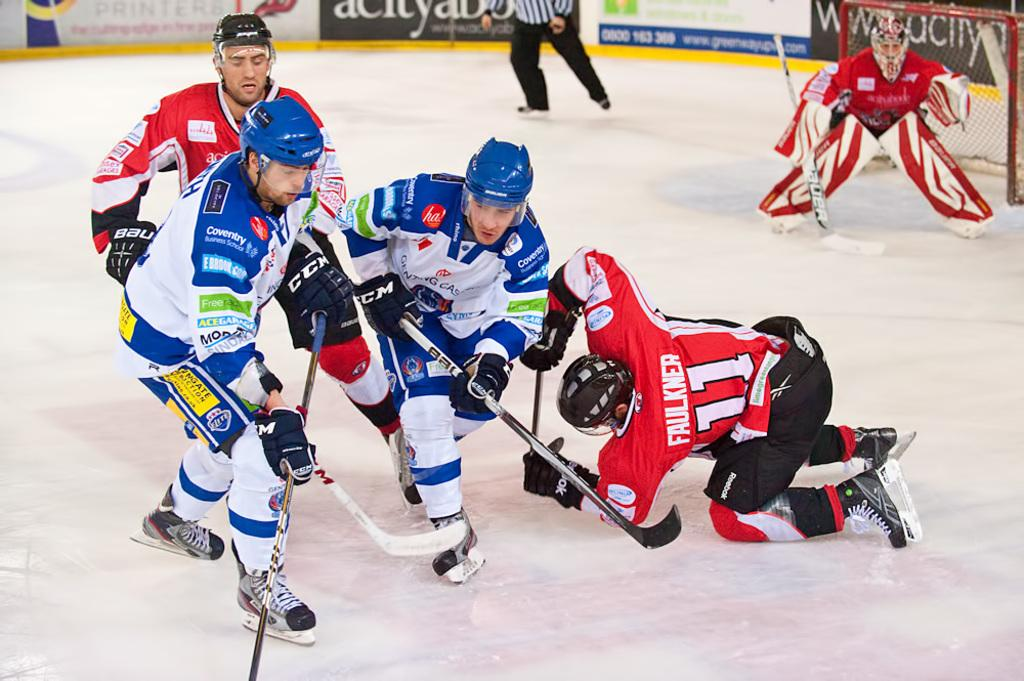<image>
Give a short and clear explanation of the subsequent image. Faulkner, number 11 on the red team, failed to stop the two opposing hockey players. 